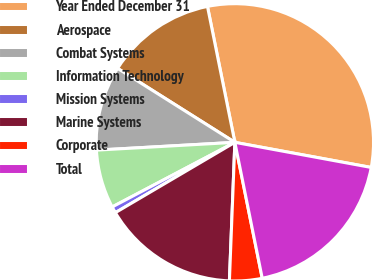<chart> <loc_0><loc_0><loc_500><loc_500><pie_chart><fcel>Year Ended December 31<fcel>Aerospace<fcel>Combat Systems<fcel>Information Technology<fcel>Mission Systems<fcel>Marine Systems<fcel>Corporate<fcel>Total<nl><fcel>31.07%<fcel>12.88%<fcel>9.85%<fcel>6.82%<fcel>0.75%<fcel>15.91%<fcel>3.79%<fcel>18.94%<nl></chart> 